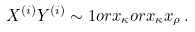Convert formula to latex. <formula><loc_0><loc_0><loc_500><loc_500>X ^ { ( i ) } Y ^ { ( i ) } \sim 1 o r x _ { \kappa } o r x _ { \kappa } x _ { \rho } \, .</formula> 